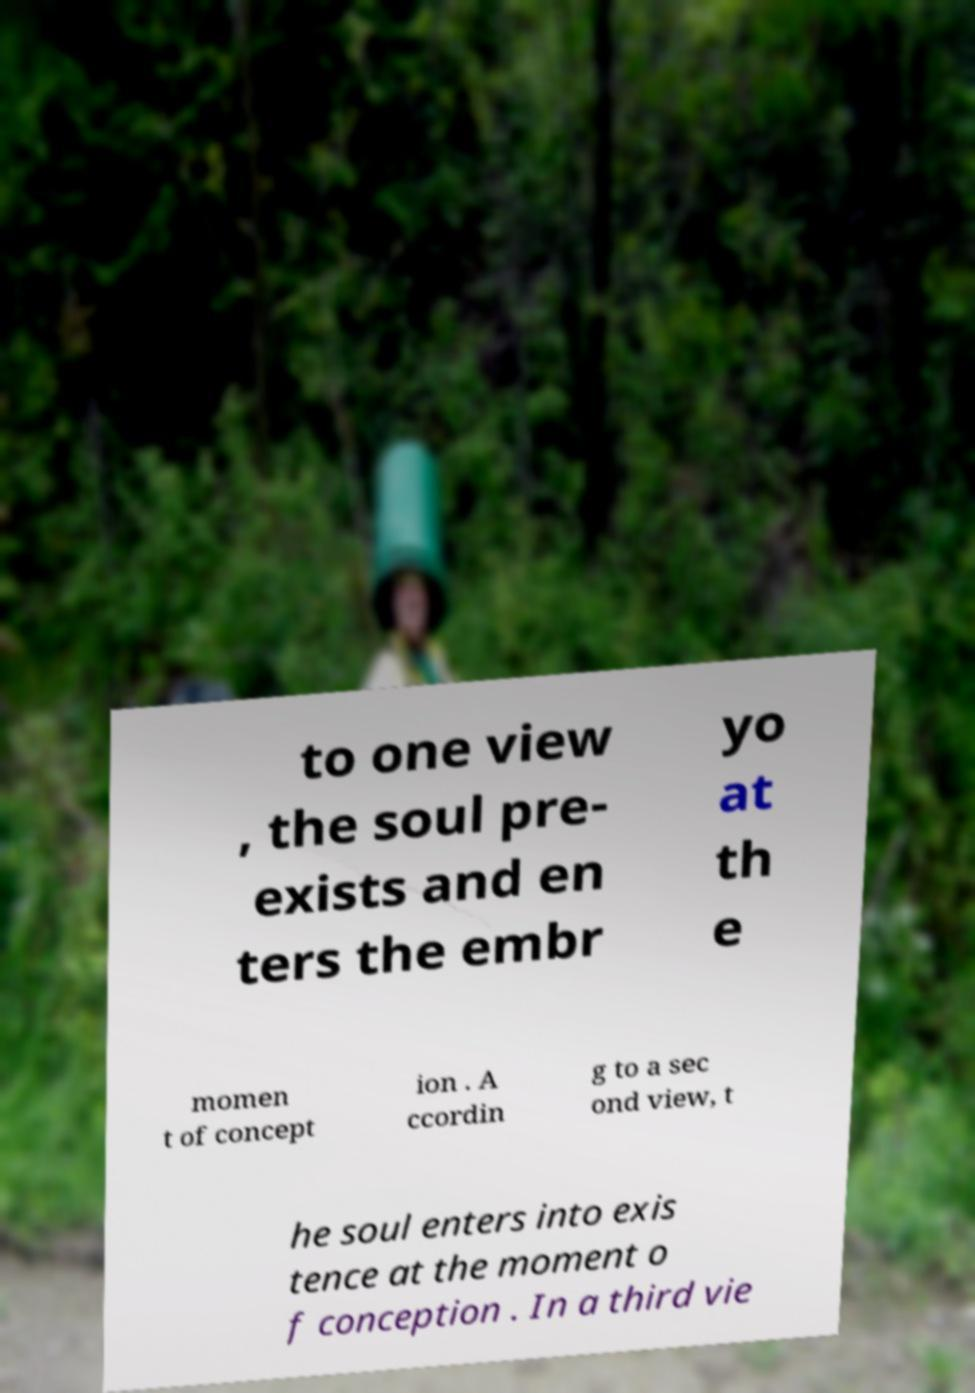Please identify and transcribe the text found in this image. to one view , the soul pre- exists and en ters the embr yo at th e momen t of concept ion . A ccordin g to a sec ond view, t he soul enters into exis tence at the moment o f conception . In a third vie 